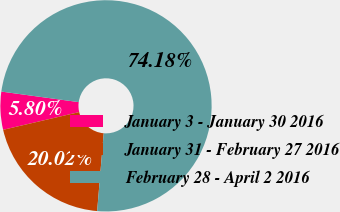Convert chart. <chart><loc_0><loc_0><loc_500><loc_500><pie_chart><fcel>January 3 - January 30 2016<fcel>January 31 - February 27 2016<fcel>February 28 - April 2 2016<nl><fcel>5.8%<fcel>20.02%<fcel>74.18%<nl></chart> 